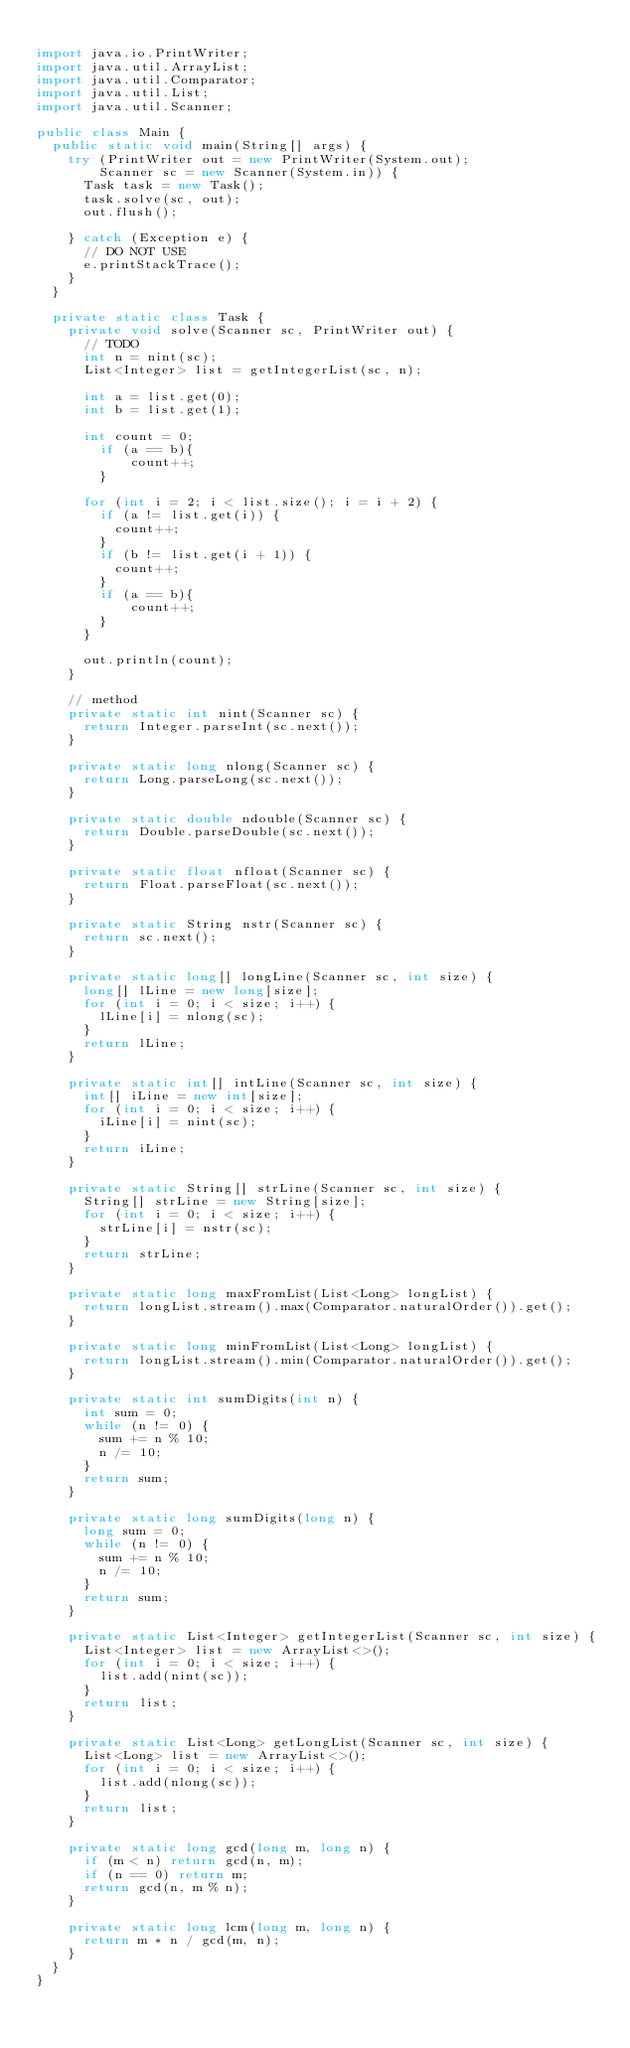Convert code to text. <code><loc_0><loc_0><loc_500><loc_500><_Java_>
import java.io.PrintWriter;
import java.util.ArrayList;
import java.util.Comparator;
import java.util.List;
import java.util.Scanner;

public class Main {
  public static void main(String[] args) {
    try (PrintWriter out = new PrintWriter(System.out);
        Scanner sc = new Scanner(System.in)) {
      Task task = new Task();
      task.solve(sc, out);
      out.flush();

    } catch (Exception e) {
      // DO NOT USE
      e.printStackTrace();
    }
  }

  private static class Task {
    private void solve(Scanner sc, PrintWriter out) {
      // TODO
      int n = nint(sc);
      List<Integer> list = getIntegerList(sc, n);

      int a = list.get(0);
      int b = list.get(1);

      int count = 0;
        if (a == b){
            count++;
        }

      for (int i = 2; i < list.size(); i = i + 2) {
        if (a != list.get(i)) {
          count++;
        }
        if (b != list.get(i + 1)) {
          count++;
        }
        if (a == b){
            count++;
        }
      }

      out.println(count);
    }

    // method
    private static int nint(Scanner sc) {
      return Integer.parseInt(sc.next());
    }

    private static long nlong(Scanner sc) {
      return Long.parseLong(sc.next());
    }

    private static double ndouble(Scanner sc) {
      return Double.parseDouble(sc.next());
    }

    private static float nfloat(Scanner sc) {
      return Float.parseFloat(sc.next());
    }

    private static String nstr(Scanner sc) {
      return sc.next();
    }

    private static long[] longLine(Scanner sc, int size) {
      long[] lLine = new long[size];
      for (int i = 0; i < size; i++) {
        lLine[i] = nlong(sc);
      }
      return lLine;
    }

    private static int[] intLine(Scanner sc, int size) {
      int[] iLine = new int[size];
      for (int i = 0; i < size; i++) {
        iLine[i] = nint(sc);
      }
      return iLine;
    }

    private static String[] strLine(Scanner sc, int size) {
      String[] strLine = new String[size];
      for (int i = 0; i < size; i++) {
        strLine[i] = nstr(sc);
      }
      return strLine;
    }

    private static long maxFromList(List<Long> longList) {
      return longList.stream().max(Comparator.naturalOrder()).get();
    }

    private static long minFromList(List<Long> longList) {
      return longList.stream().min(Comparator.naturalOrder()).get();
    }

    private static int sumDigits(int n) {
      int sum = 0;
      while (n != 0) {
        sum += n % 10;
        n /= 10;
      }
      return sum;
    }

    private static long sumDigits(long n) {
      long sum = 0;
      while (n != 0) {
        sum += n % 10;
        n /= 10;
      }
      return sum;
    }

    private static List<Integer> getIntegerList(Scanner sc, int size) {
      List<Integer> list = new ArrayList<>();
      for (int i = 0; i < size; i++) {
        list.add(nint(sc));
      }
      return list;
    }

    private static List<Long> getLongList(Scanner sc, int size) {
      List<Long> list = new ArrayList<>();
      for (int i = 0; i < size; i++) {
        list.add(nlong(sc));
      }
      return list;
    }

    private static long gcd(long m, long n) {
      if (m < n) return gcd(n, m);
      if (n == 0) return m;
      return gcd(n, m % n);
    }

    private static long lcm(long m, long n) {
      return m * n / gcd(m, n);
    }
  }
}
</code> 